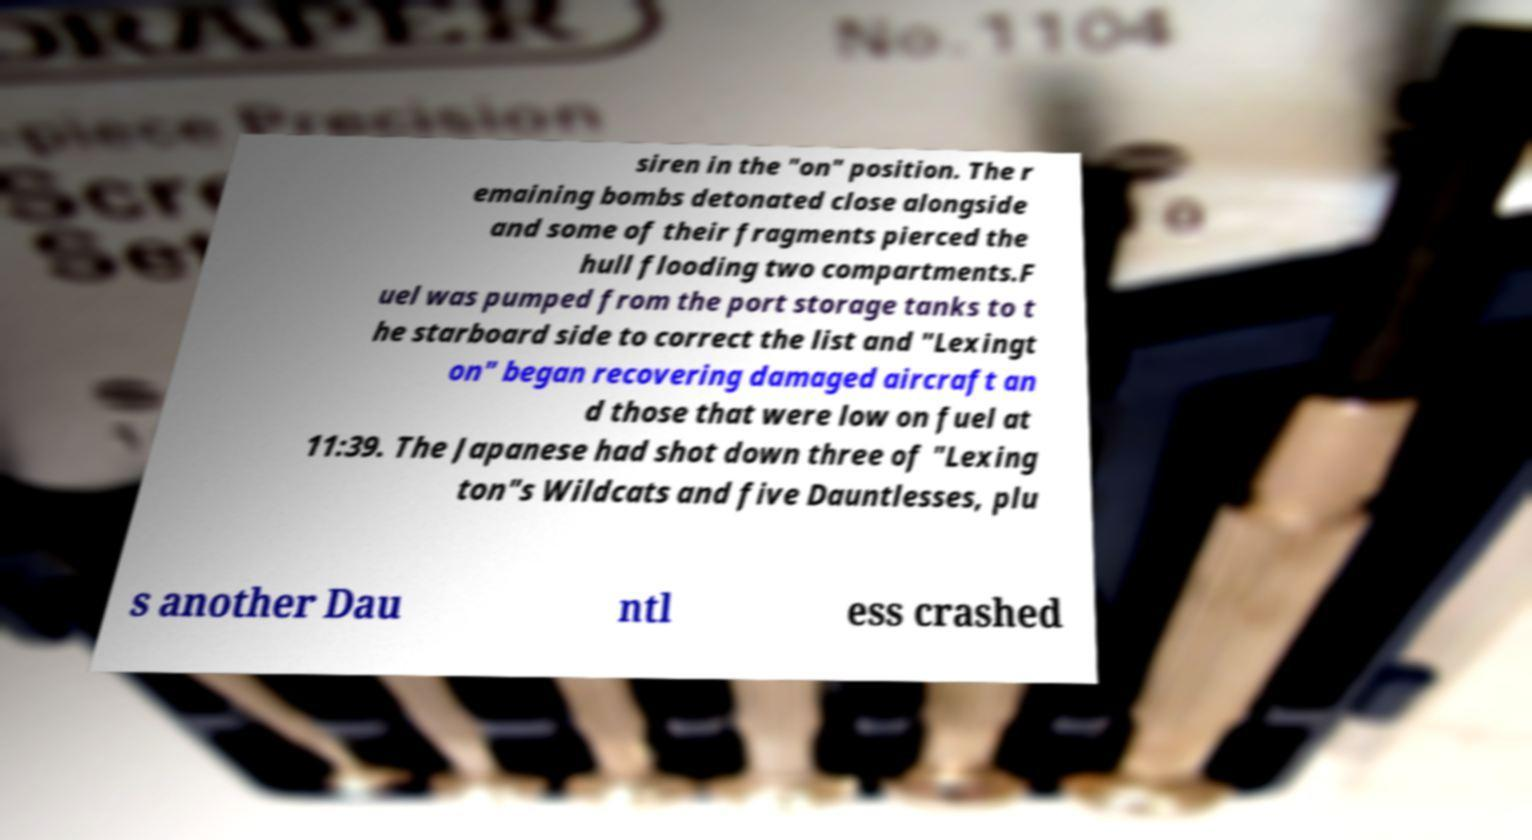Please read and relay the text visible in this image. What does it say? siren in the "on" position. The r emaining bombs detonated close alongside and some of their fragments pierced the hull flooding two compartments.F uel was pumped from the port storage tanks to t he starboard side to correct the list and "Lexingt on" began recovering damaged aircraft an d those that were low on fuel at 11:39. The Japanese had shot down three of "Lexing ton"s Wildcats and five Dauntlesses, plu s another Dau ntl ess crashed 